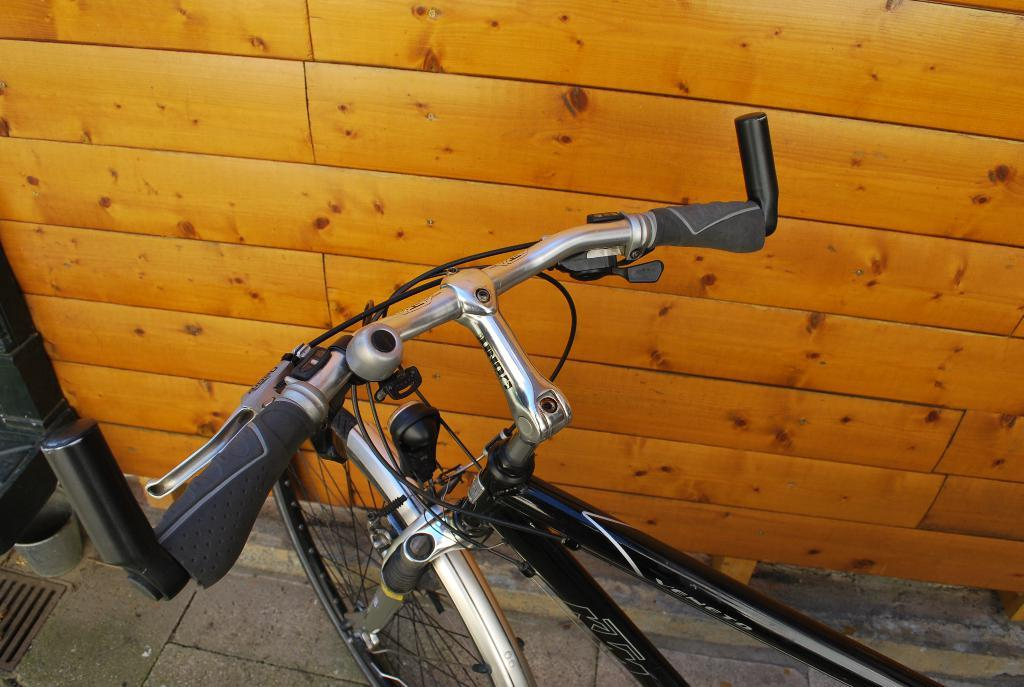What object is on the floor in the image? There is a bicycle on the floor in the image. What is located beside the bicycle? There is a wooden plank beside the bicycle. What type of soup is being prepared on the cannon in the image? There is no cannon or soup present in the image; it only features a bicycle and a wooden plank. 